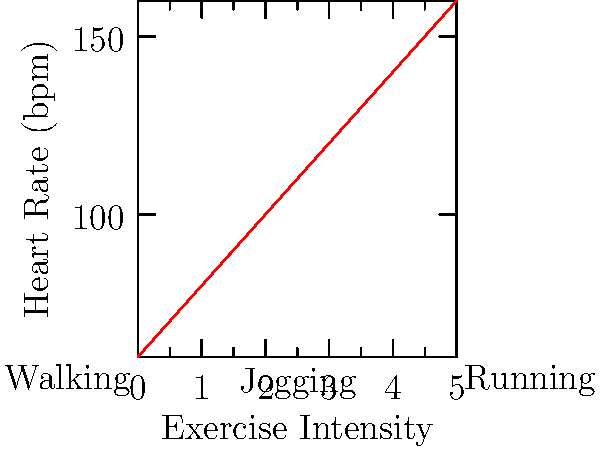As a busy dad who often finds excuses to skip workouts, you decide to track your heart rate during different exercise intensities. Looking at the graph, what's the approximate increase in heart rate (in beats per minute) when transitioning from walking to jogging? Let's break this down step-by-step:

1. Identify the exercise intensities:
   - Walking is at the lower end of the x-axis
   - Jogging is in the middle of the x-axis

2. Estimate heart rates:
   - For walking (x ≈ 1), the heart rate is approximately 80 bpm
   - For jogging (x ≈ 3), the heart rate is approximately 120 bpm

3. Calculate the difference:
   $\text{Increase} = \text{Jogging heart rate} - \text{Walking heart rate}$
   $\text{Increase} = 120 \text{ bpm} - 80 \text{ bpm} = 40 \text{ bpm}$

Therefore, the approximate increase in heart rate when transitioning from walking to jogging is 40 beats per minute.
Answer: 40 bpm 